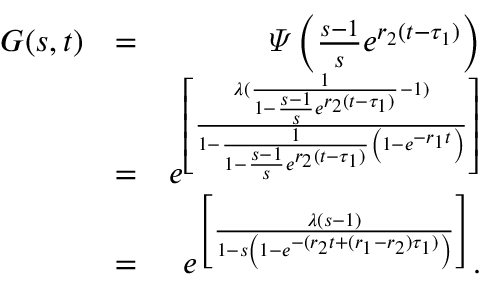<formula> <loc_0><loc_0><loc_500><loc_500>\begin{array} { r l r } { G ( s , t ) } & { = } & { \varPsi \left ( \frac { s - 1 } { s } e ^ { r _ { 2 } ( t - \tau _ { 1 } ) } \right ) } \\ & { = } & { e ^ { \left [ \frac { \lambda ( \frac { 1 } { 1 - \frac { s - 1 } { s } e ^ { r _ { 2 } ( t - \tau _ { 1 } ) } } - 1 ) } { 1 - \frac { 1 } { 1 - \frac { s - 1 } { s } e ^ { r _ { 2 } ( t - \tau _ { 1 } ) } } \left ( 1 - e ^ { - r _ { 1 } t } \right ) } \right ] } } \\ & { = } & { e ^ { \left [ \frac { \lambda ( s - 1 ) } { 1 - s \left ( 1 - e ^ { - ( r _ { 2 } t + ( r _ { 1 } - r _ { 2 } ) \tau _ { 1 } ) } \right ) } \right ] } . } \end{array}</formula> 